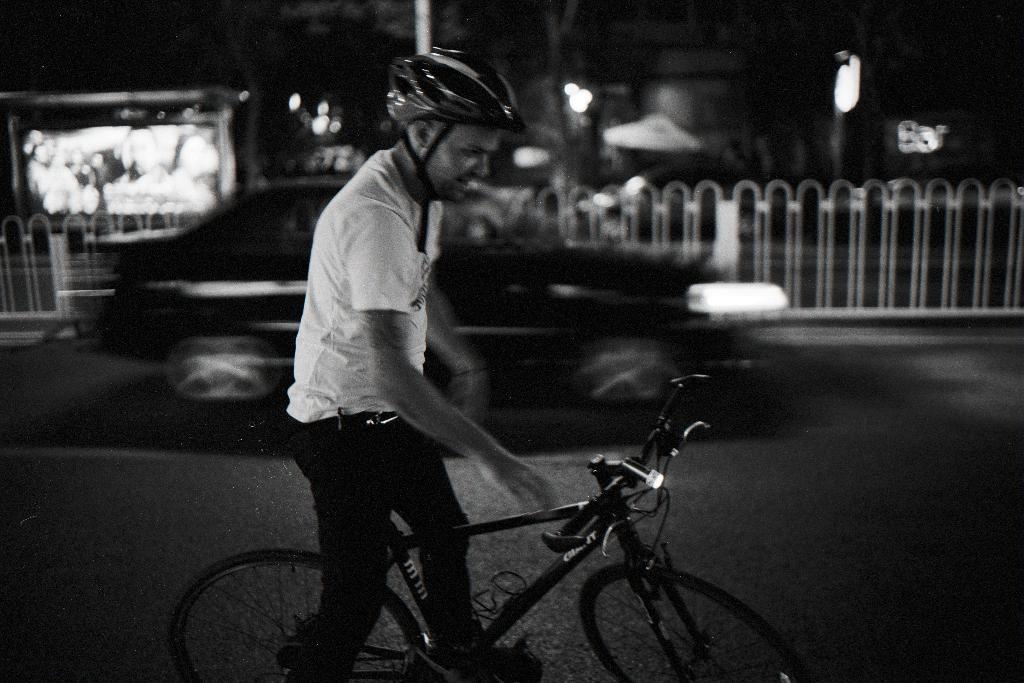In one or two sentences, can you explain what this image depicts? As we can see in the image there are lights, a man and a bicycle. 